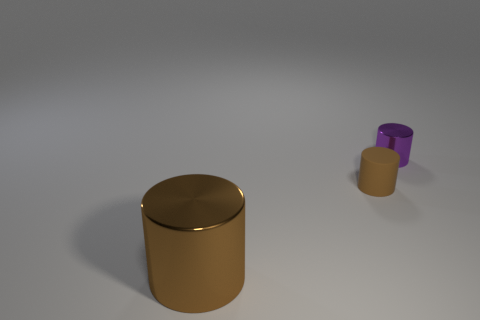How many objects are either tiny rubber things that are in front of the purple cylinder or big blue metallic spheres?
Ensure brevity in your answer.  1. Is the color of the small matte cylinder the same as the big cylinder?
Offer a very short reply. Yes. What number of other objects are the same shape as the tiny rubber object?
Your answer should be compact. 2. How many brown objects are big shiny cylinders or rubber things?
Keep it short and to the point. 2. There is a small cylinder that is made of the same material as the large object; what is its color?
Provide a succinct answer. Purple. Are the tiny purple thing that is to the right of the large object and the thing to the left of the small brown matte object made of the same material?
Give a very brief answer. Yes. What size is the matte cylinder that is the same color as the large metallic cylinder?
Your response must be concise. Small. There is a small thing behind the small brown cylinder; what material is it?
Offer a terse response. Metal. Does the shiny thing behind the big metal cylinder have the same shape as the shiny thing that is to the left of the small rubber object?
Offer a terse response. Yes. What material is the other big thing that is the same color as the matte object?
Your answer should be compact. Metal. 